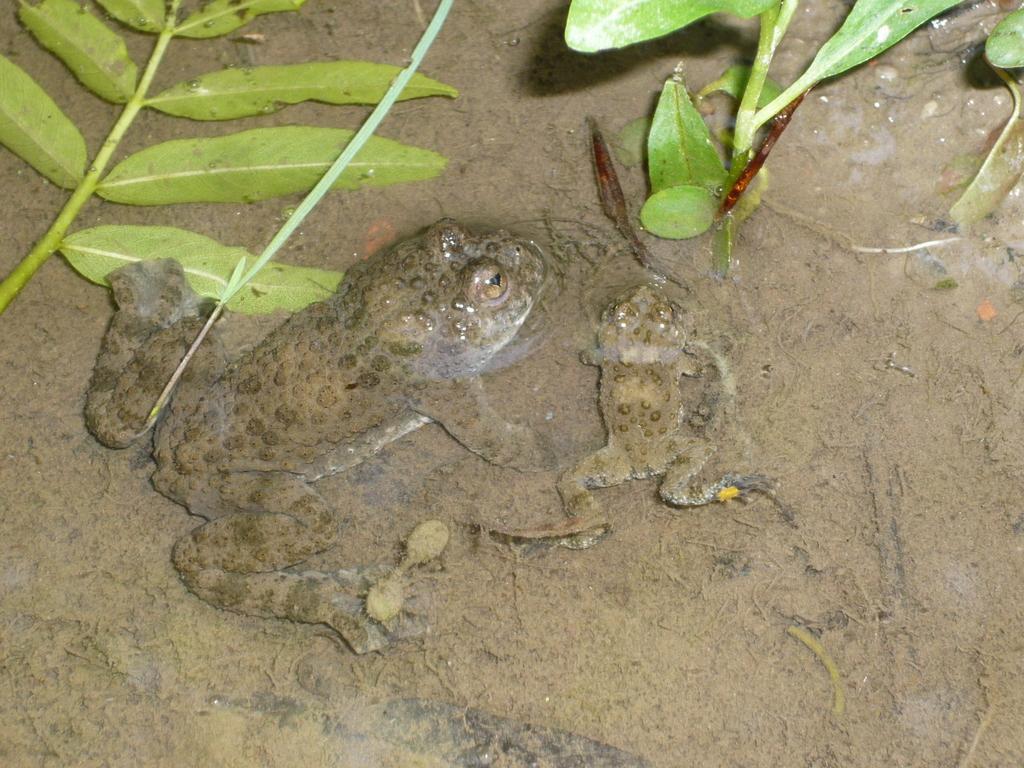Can you describe this image briefly? In this image there are two frogs in the sand. At the top there are green leaves and small plants. 